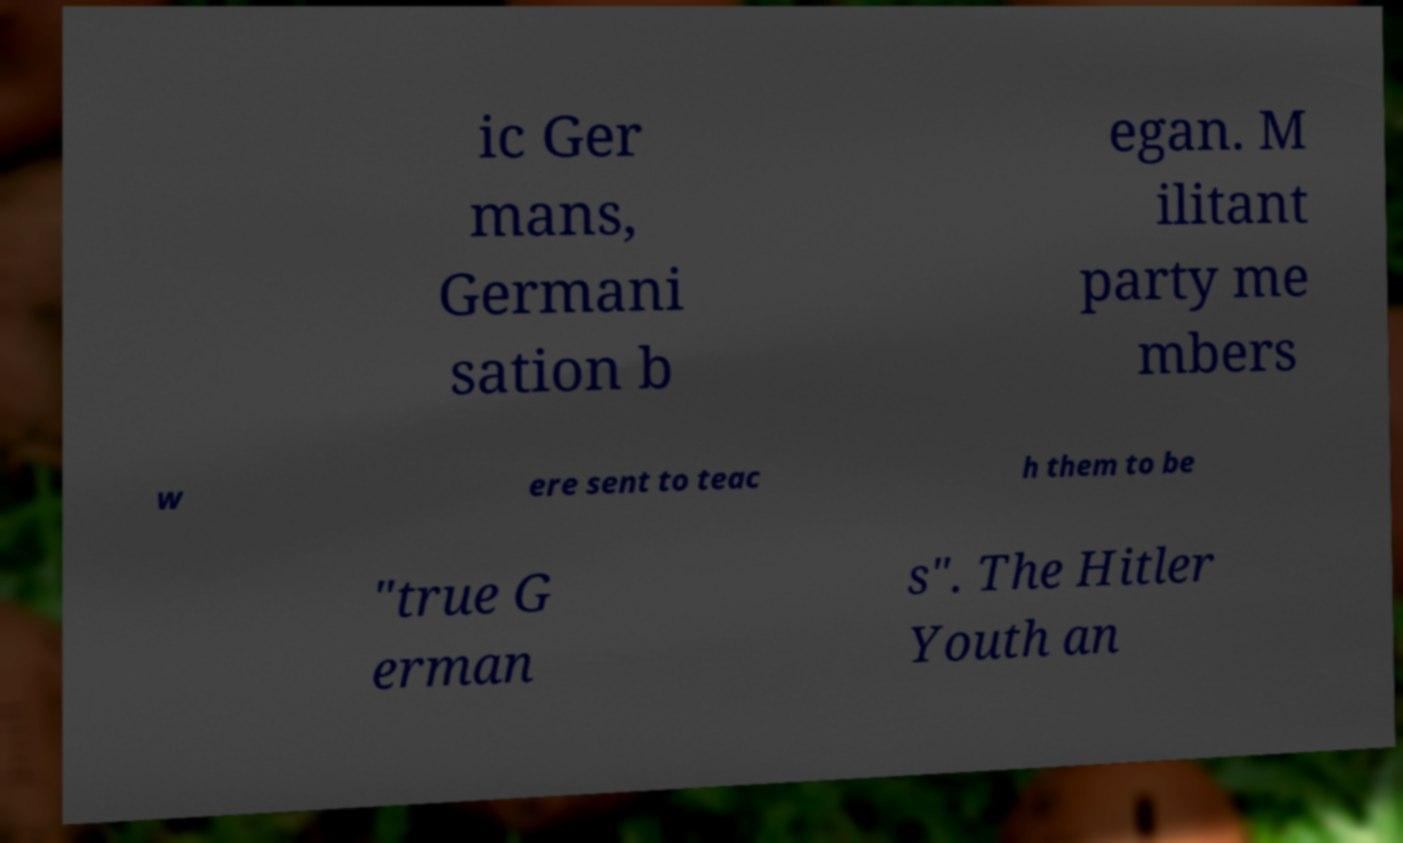What messages or text are displayed in this image? I need them in a readable, typed format. ic Ger mans, Germani sation b egan. M ilitant party me mbers w ere sent to teac h them to be "true G erman s". The Hitler Youth an 